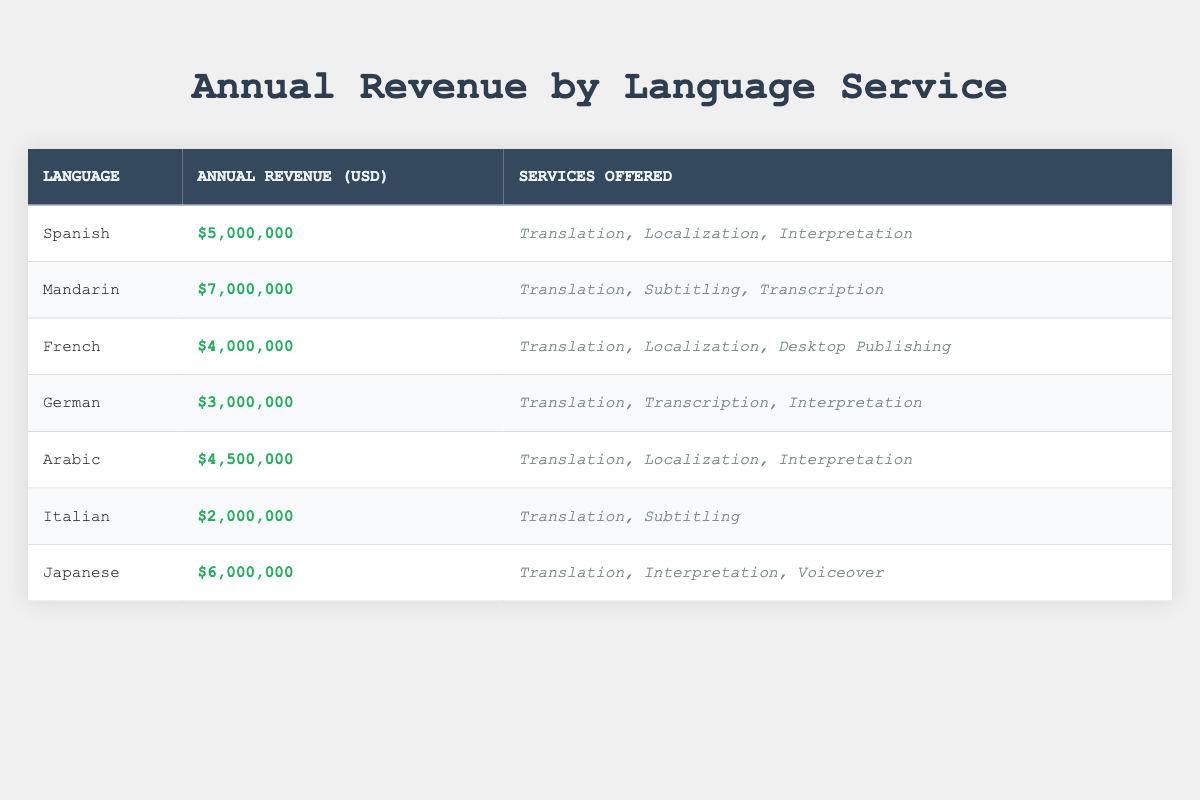What is the annual revenue generated for Spanish services? From the table, the annual revenue for Spanish services is clearly listed as five million dollars.
Answer: Five million dollars How many services are offered in German? The table indicates that the services offered in German are Translation, Transcription, and Interpretation. This totals three services.
Answer: Three services Which language has the highest annual revenue? Upon examining the annual revenue column, Mandarin generates the highest revenue at seven million dollars, surpassing all other languages listed.
Answer: Seven million dollars What is the total annual revenue of French and Arabic combined? The annual revenue for French is four million dollars and for Arabic, it's four and a half million dollars. Adding these values together gives four million plus four and a half million equals eight and a half million dollars.
Answer: Eight and a half million dollars Is Italian one of the top three languages by annual revenue? By comparing the annual revenues listed, Italian, which has two million dollars, is less than the top three (Mandarin, Japanese, and Spanish). Therefore, it is not in the top three.
Answer: No Which services are offered for Japanese? The table specifies that for Japanese, the services offered are Translation, Interpretation, and Voiceover, totaling three distinct services.
Answer: Translation, Interpretation, Voiceover What is the average annual revenue across all languages listed? To find the average, first sum the annual revenues: five million (Spanish) + seven million (Mandarin) + four million (French) + three million (German) + four and a half million (Arabic) + two million (Italian) + six million (Japanese) equals thirty-one and a half million dollars. Since there are seven languages, the average is thirty-one and a half million divided by seven, which is approximately four and a half million dollars.
Answer: Four and a half million dollars Which language offers subtitling as a service? The data shows that Mandarin and Italian are the two languages that offer subtitling as one of their services.
Answer: Mandarin, Italian What is the difference in annual revenue between Arabic and German? Arabic has an annual revenue of four and a half million dollars while German has three million dollars. The difference is found by subtracting the two values: four and a half million minus three million equals one and a half million dollars.
Answer: One and a half million dollars 